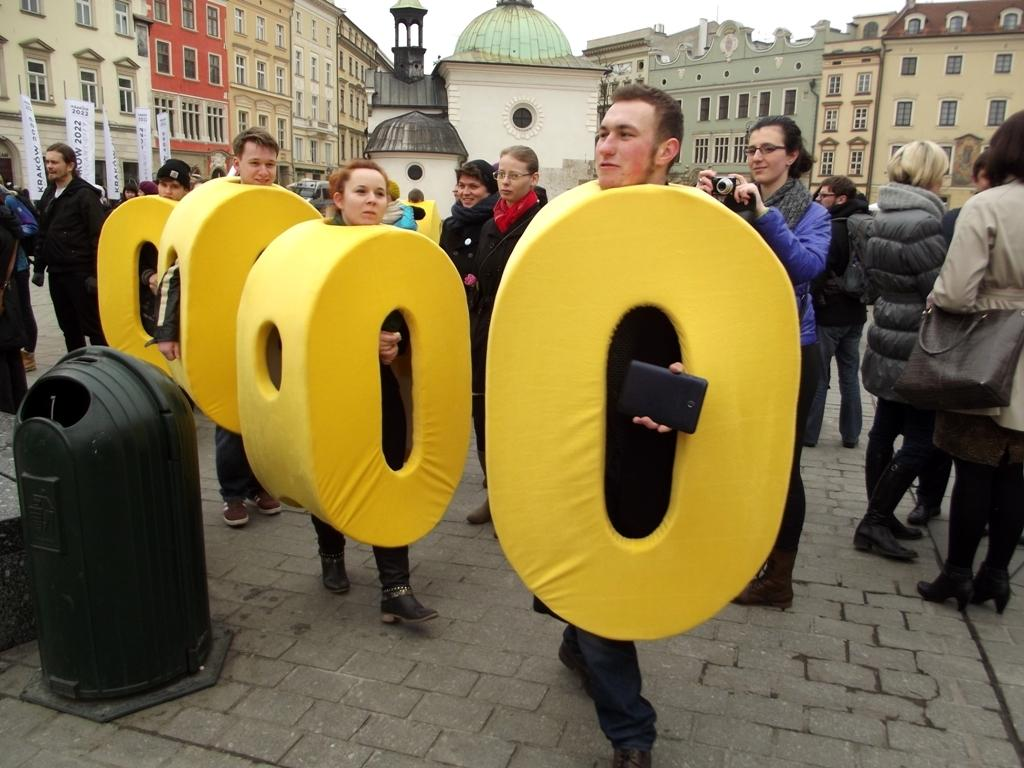What is happening with the groups of people in the image? There are groups of people standing in the image. What can be observed about the attire of some people in the image? Some people are wearing fancy dress. What is the person holding in the image? There is a person holding a camera in the image. What can be seen in the distance in the image? There are buildings visible in the background of the image, and the sky is also visible. What type of butter is being used to create a thrilling effect in the image? There is no butter or thrilling effect present in the image; it features groups of people, some wearing fancy dress, and a person holding a camera. 